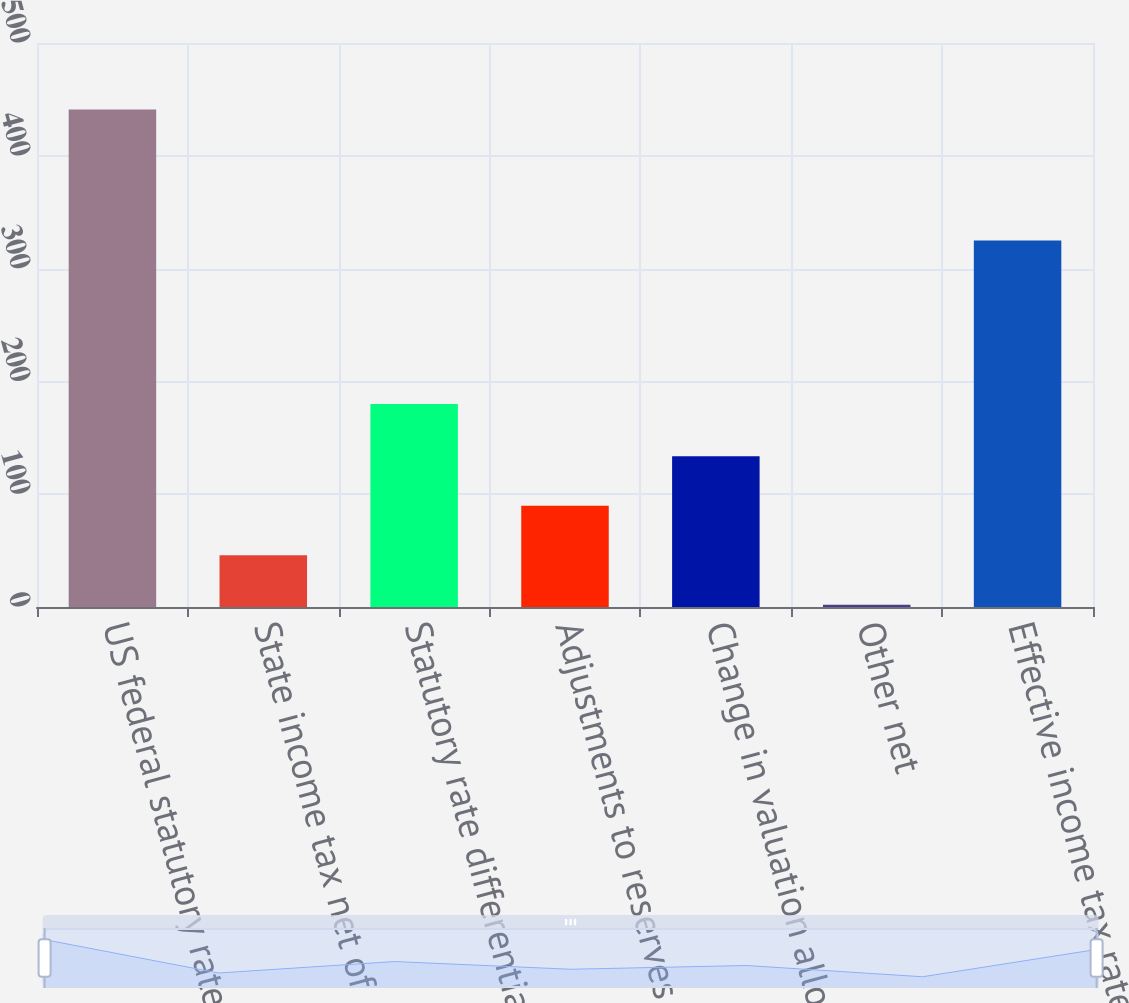<chart> <loc_0><loc_0><loc_500><loc_500><bar_chart><fcel>US federal statutory rate<fcel>State income tax net of<fcel>Statutory rate differential<fcel>Adjustments to reserves and<fcel>Change in valuation allowances<fcel>Other net<fcel>Effective income tax rate<nl><fcel>441<fcel>45.9<fcel>180<fcel>89.8<fcel>133.7<fcel>2<fcel>325<nl></chart> 